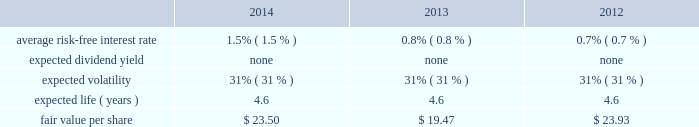Edwards lifesciences corporation notes to consolidated financial statements ( continued ) 13 .
Common stock ( continued ) the company also maintains the nonemployee directors stock incentive compensation program ( the 2018 2018nonemployee directors program 2019 2019 ) .
Under the nonemployee directors program , each nonemployee director may receive annually up to 20000 stock options or 8000 restricted stock units of the company 2019s common stock , or a combination thereof , provided that in no event may the total value of the combined annual award exceed $ 0.2 million .
Each option and restricted stock unit award granted in 2011 or prior generally vests in three equal annual installments .
Each option and restricted stock unit award granted after 2011 generally vests after one year .
Additionally , each nonemployee director may elect to receive all or a portion of the annual cash retainer to which the director is otherwise entitled through the issuance of stock options or restricted shares .
Each option received as a deferral of the cash retainer immediately vests on the grant date , and each restricted share award vests after one year .
Upon a director 2019s initial election to the board , the director receives an initial grant of stock options equal to a fair market value on grant date of $ 0.2 million , not to exceed 10000 shares .
These grants vest over three years from the date of grant .
Under the nonemployee directors program , an aggregate of 1.4 million shares of the company 2019s common stock has been authorized for issuance .
The company has an employee stock purchase plan for united states employees and a plan for international employees ( collectively 2018 2018espp 2019 2019 ) .
Under the espp , eligible employees may purchase shares of the company 2019s common stock at 85% ( 85 % ) of the lower of the fair market value of edwards lifesciences common stock on the effective date of subscription or the date of purchase .
Under the espp , employees can authorize the company to withhold up to 12% ( 12 % ) of their compensation for common stock purchases , subject to certain limitations .
The espp is available to all active employees of the company paid from the united states payroll and to eligible employees of the company outside the united states , to the extent permitted by local law .
The espp for united states employees is qualified under section 423 of the internal revenue code .
The number of shares of common stock authorized for issuance under the espp was 6.9 million shares .
The fair value of each option award and employee stock purchase subscription is estimated on the date of grant using the black-scholes option valuation model that uses the assumptions noted in the tables .
The risk-free interest rate is estimated using the u.s .
Treasury yield curve and is based on the expected term of the award .
Expected volatility is estimated based on a blend of the weighted-average of the historical volatility of edwards lifesciences 2019 stock and the implied volatility from traded options on edwards lifesciences 2019 stock .
The expected term of awards granted is estimated from the vesting period of the award , as well as historical exercise behavior , and represents the period of time that awards granted are expected to be outstanding .
The company uses historical data to estimate forfeitures and has estimated an annual forfeiture rate of 5.4% ( 5.4 % ) .
The black-scholes option pricing model was used with the following weighted-average assumptions for options granted during the following periods : option awards .

What is the expected change according to the model in the fair value per share between 2012 and 2013? 
Computations: (19.47 - 23.93)
Answer: -4.46. 